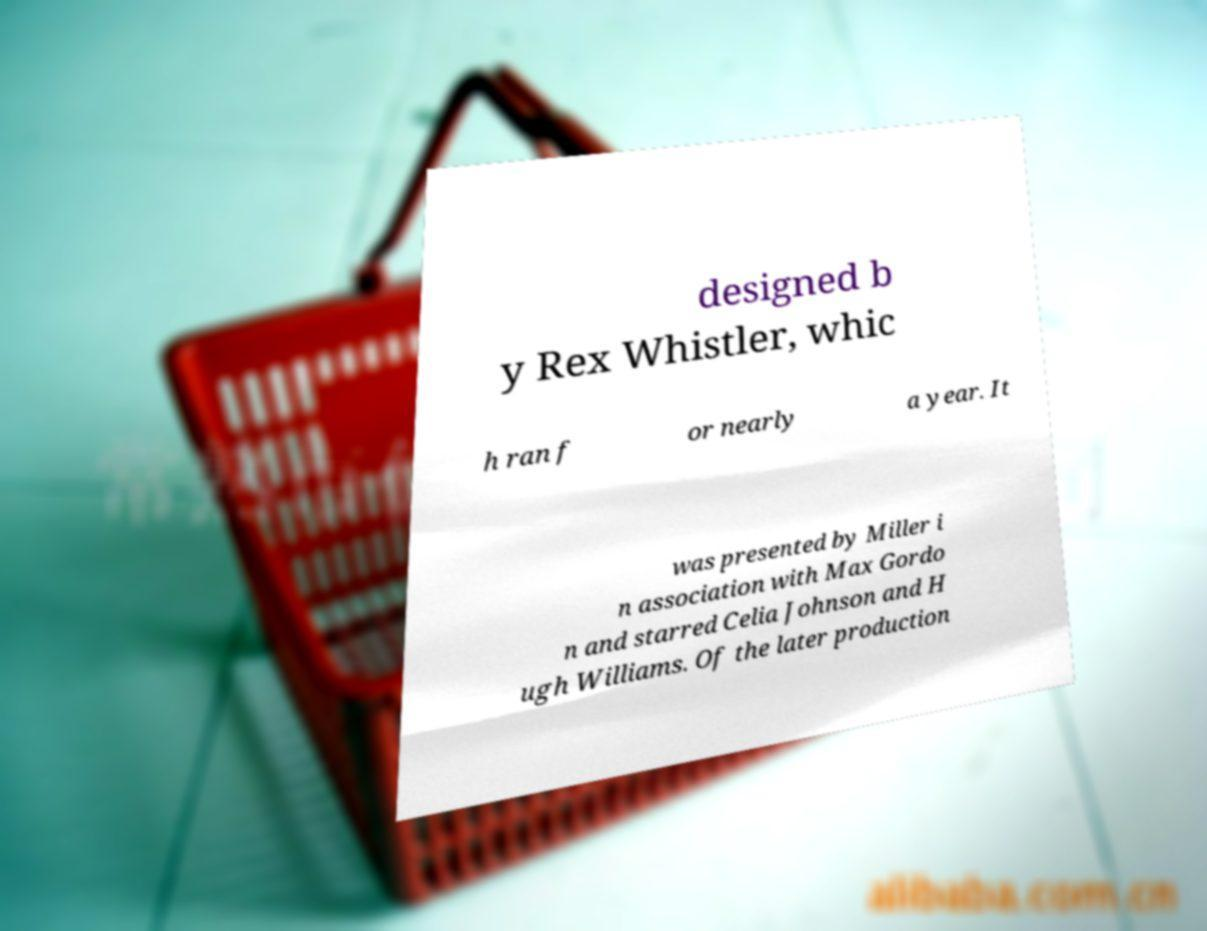I need the written content from this picture converted into text. Can you do that? designed b y Rex Whistler, whic h ran f or nearly a year. It was presented by Miller i n association with Max Gordo n and starred Celia Johnson and H ugh Williams. Of the later production 